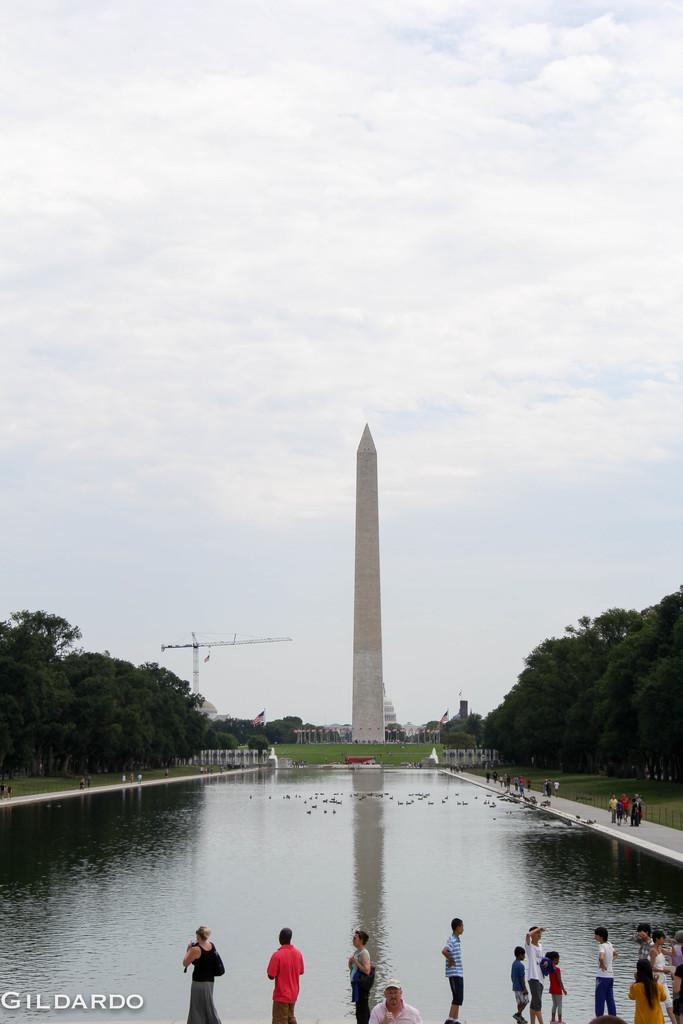How many people are in the image? There is a group of people standing in the image. What is visible in the image besides the people? Water, a tower, trees, and the sky are visible in the image. What is the background of the image? The sky is visible in the background of the image. Is there any indication of the image's origin or ownership? Yes, there is a watermark on the image. What type of bottle is being used to perform a trick in the image? There is no bottle or trick present in the image. What is the condition of the trees in the image? The provided facts do not mention the condition of the trees; only their presence is noted. 